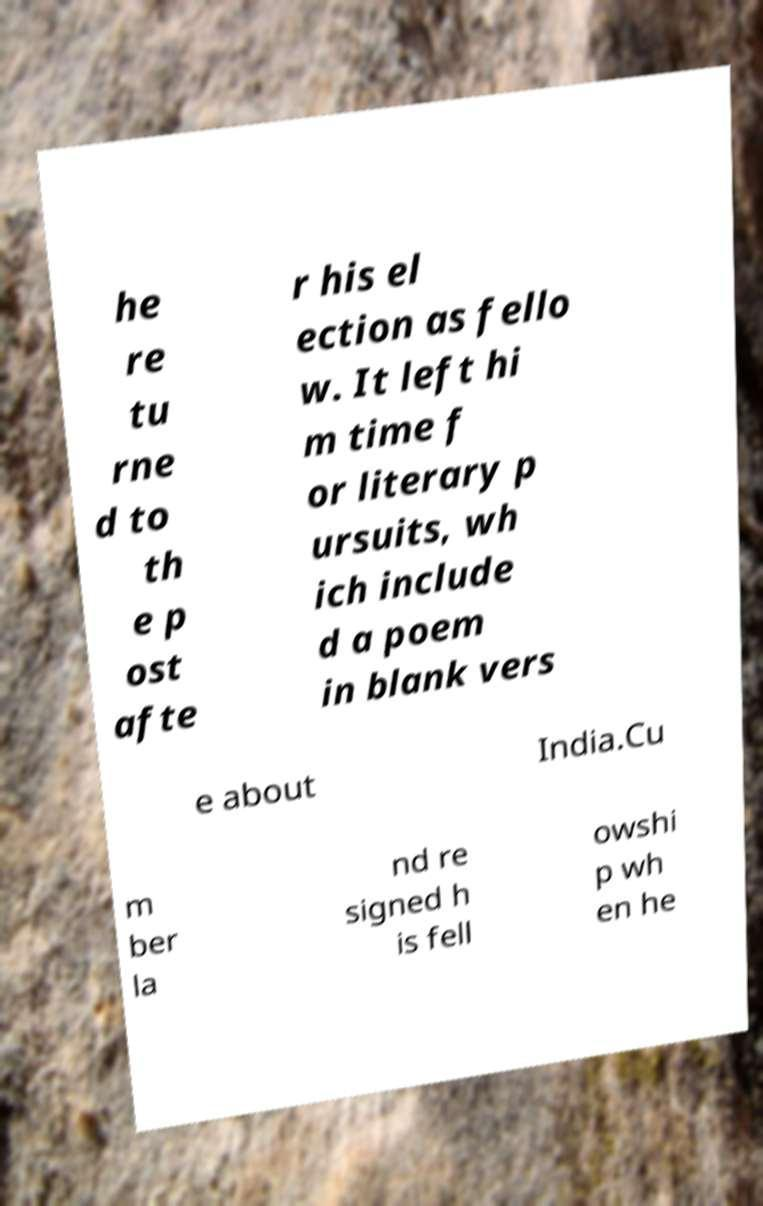Can you read and provide the text displayed in the image?This photo seems to have some interesting text. Can you extract and type it out for me? he re tu rne d to th e p ost afte r his el ection as fello w. It left hi m time f or literary p ursuits, wh ich include d a poem in blank vers e about India.Cu m ber la nd re signed h is fell owshi p wh en he 